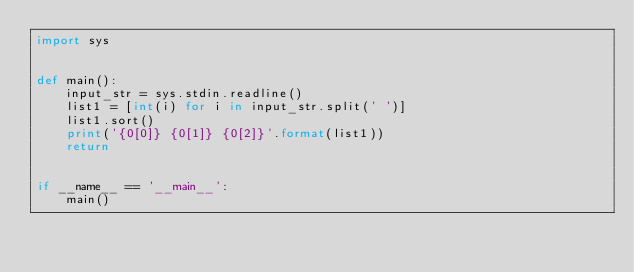Convert code to text. <code><loc_0><loc_0><loc_500><loc_500><_Python_>import sys


def main():
    input_str = sys.stdin.readline()
    list1 = [int(i) for i in input_str.split(' ')]
    list1.sort()
    print('{0[0]} {0[1]} {0[2]}'.format(list1))
    return


if __name__ == '__main__':
    main()

</code> 